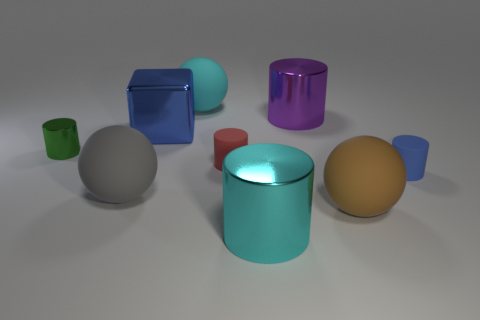Subtract all green cylinders. How many cylinders are left? 4 Subtract all gray balls. How many balls are left? 2 Subtract all green cubes. Subtract all purple cylinders. How many cubes are left? 1 Subtract all yellow cubes. How many blue cylinders are left? 1 Add 8 large gray spheres. How many large gray spheres are left? 9 Add 4 big gray metallic balls. How many big gray metallic balls exist? 4 Subtract 1 blue blocks. How many objects are left? 8 Subtract all cylinders. How many objects are left? 4 Subtract 2 balls. How many balls are left? 1 Subtract all tiny yellow metallic balls. Subtract all rubber spheres. How many objects are left? 6 